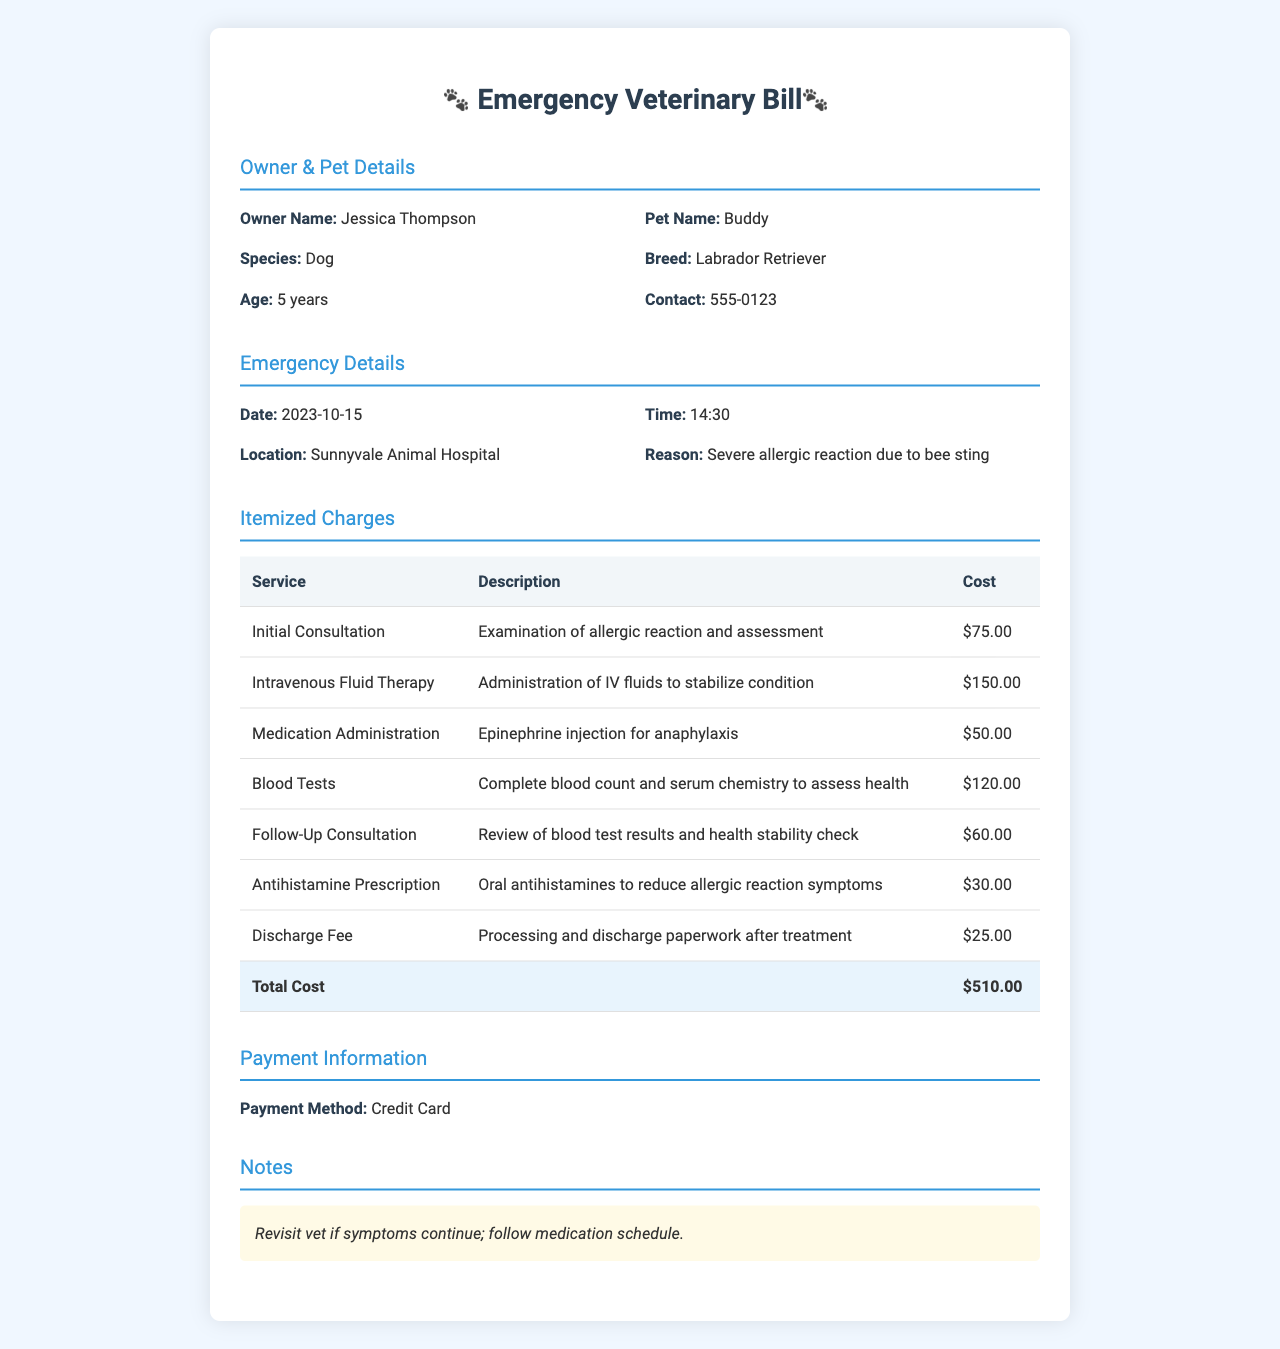What is the owner's name? The owner's name is listed in the document under Owner & Pet Details.
Answer: Jessica Thompson What was the emergency reason? The reason for the emergency is stated in the Emergency Details section.
Answer: Severe allergic reaction due to bee sting What is the date of the emergency? The date of the emergency is provided in the Emergency Details section.
Answer: 2023-10-15 What is the cost of the Initial Consultation? The cost of the Initial Consultation is found in the Itemized Charges table.
Answer: $75.00 How much did the Discharge Fee cost? The Discharge Fee is detailed in the Itemized Charges table.
Answer: $25.00 What medications were administered? The medications are listed under the Itemized Charges section, detailing specific treatments.
Answer: Epinephrine injection, Antihistamine Prescription What is the total cost of the services rendered? The total cost is calculated and provided at the bottom of the Itemized Charges table.
Answer: $510.00 What method of payment was used? The payment method is specified in the Payment Information section of the document.
Answer: Credit Card What is the follow-up recommendation for the pet? The recommendation is noted in the Notes section of the document.
Answer: Revisit vet if symptoms continue; follow medication schedule 